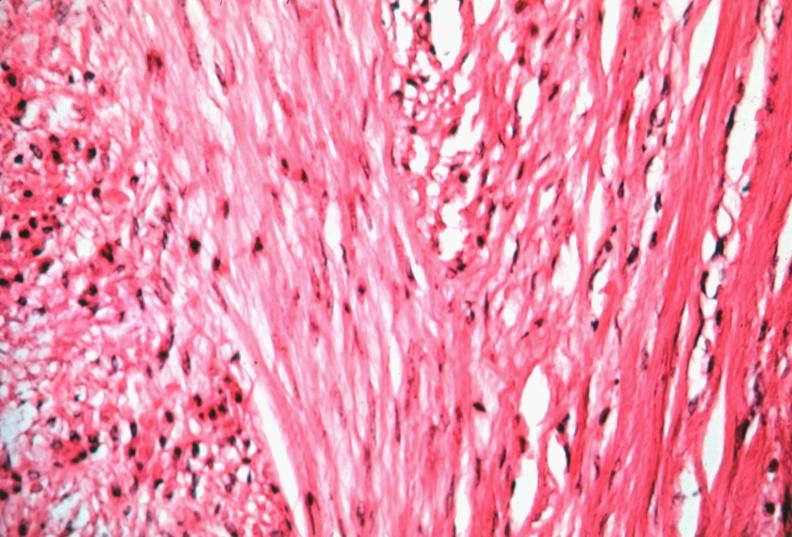what is present?
Answer the question using a single word or phrase. Female reproductive 